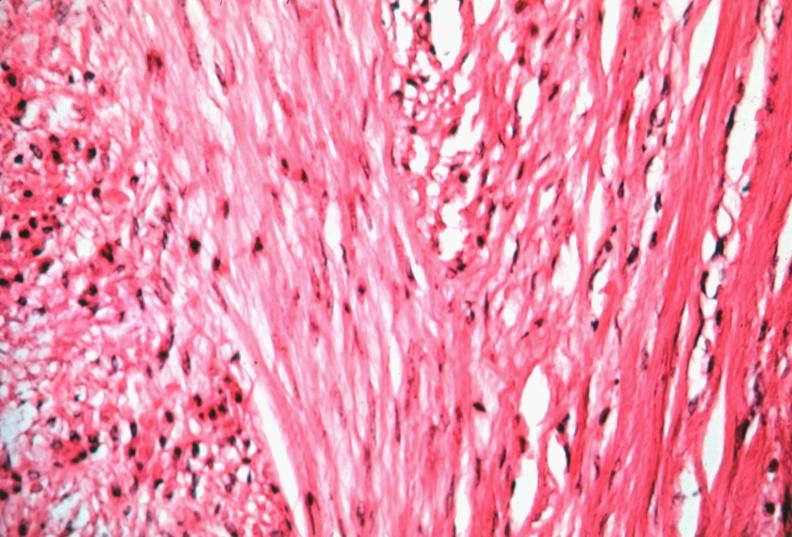what is present?
Answer the question using a single word or phrase. Female reproductive 